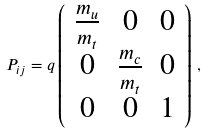Convert formula to latex. <formula><loc_0><loc_0><loc_500><loc_500>P _ { i j } = q \left ( \begin{array} { c c c } \frac { m _ { u } } { m _ { t } } & 0 & 0 \\ 0 & \frac { m _ { c } } { m _ { t } } & 0 \\ 0 & 0 & 1 \end{array} \right ) \, ,</formula> 